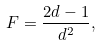<formula> <loc_0><loc_0><loc_500><loc_500>F = \frac { 2 d - 1 } { d ^ { 2 } } ,</formula> 